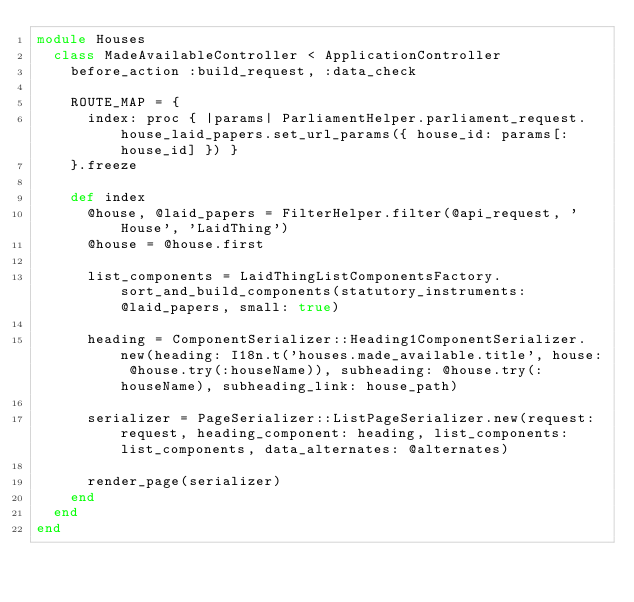Convert code to text. <code><loc_0><loc_0><loc_500><loc_500><_Ruby_>module Houses
  class MadeAvailableController < ApplicationController
    before_action :build_request, :data_check

    ROUTE_MAP = {
      index: proc { |params| ParliamentHelper.parliament_request.house_laid_papers.set_url_params({ house_id: params[:house_id] }) }
    }.freeze

    def index
      @house, @laid_papers = FilterHelper.filter(@api_request, 'House', 'LaidThing')
      @house = @house.first

      list_components = LaidThingListComponentsFactory.sort_and_build_components(statutory_instruments: @laid_papers, small: true)

      heading = ComponentSerializer::Heading1ComponentSerializer.new(heading: I18n.t('houses.made_available.title', house: @house.try(:houseName)), subheading: @house.try(:houseName), subheading_link: house_path)

      serializer = PageSerializer::ListPageSerializer.new(request: request, heading_component: heading, list_components: list_components, data_alternates: @alternates)

      render_page(serializer)
    end
  end
end
</code> 